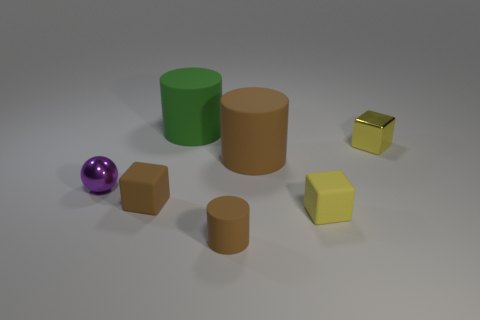What textures are visible on these objects? The textures visible in the image suggest that the purple ball has a shiny, perhaps metallic surface, reflecting some light. The green and brown cylinders appear to have a matte finish, like painted wood or plastic. The brown cube looks similar in texture to the cylinders. The small yellow cube has a rubber-like texture, discernible by its matte and slightly bumpy surface. Lastly, the golden cube has a reflective, polished metal appearance. 